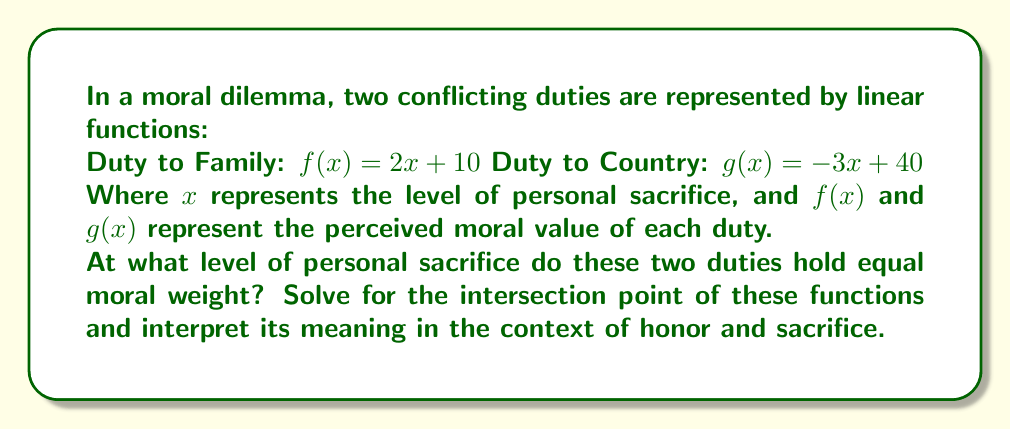Solve this math problem. To find the intersection point of these two linear functions, we need to solve the equation:

$f(x) = g(x)$

Substituting the given functions:

$2x + 10 = -3x + 40$

Now, let's solve this equation step by step:

1) Add $3x$ to both sides:
   $5x + 10 = 40$

2) Subtract 10 from both sides:
   $5x = 30$

3) Divide both sides by 5:
   $x = 6$

To find the y-coordinate of the intersection point, we can substitute $x = 6$ into either of the original functions. Let's use $f(x)$:

$f(6) = 2(6) + 10 = 12 + 10 = 22$

Therefore, the point of intersection is (6, 22).

Interpretation:
The x-coordinate (6) represents the level of personal sacrifice where the two duties hold equal moral weight. The y-coordinate (22) represents the perceived moral value of either duty at this point of equilibrium.

This intersection suggests that at a moderate level of personal sacrifice (6 units), the moral value of duty to family and duty to country become equal (22 units). It implies that up to this point, duty to family holds more weight (as its line is higher), but beyond this point, duty to country becomes more significant.

This mathematical representation illustrates the complex nature of moral decisions, where increasing personal sacrifice can shift the balance between conflicting duties.
Answer: The intersection point is (6, 22). This means that at a personal sacrifice level of 6, both duties hold equal moral weight with a value of 22. 